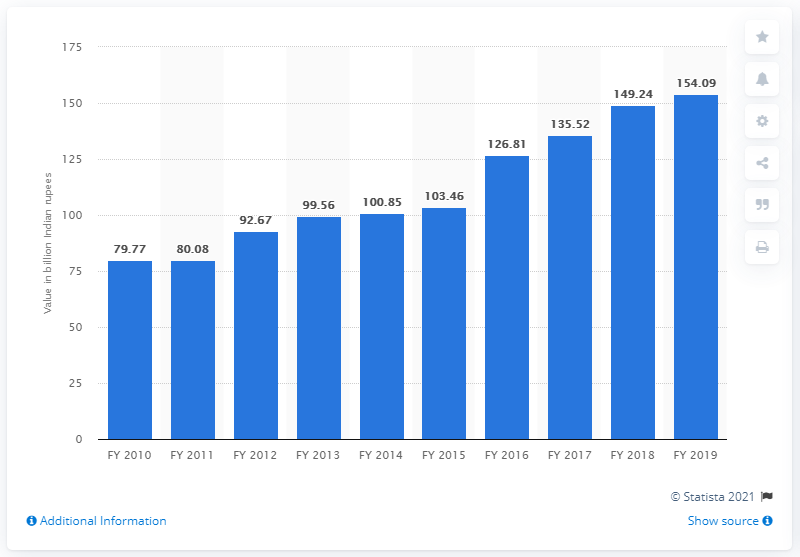Point out several critical features in this image. In the fiscal year 2019, a significant amount of Indian rupees was generated at major ports in India, reaching 154.09 crores. 